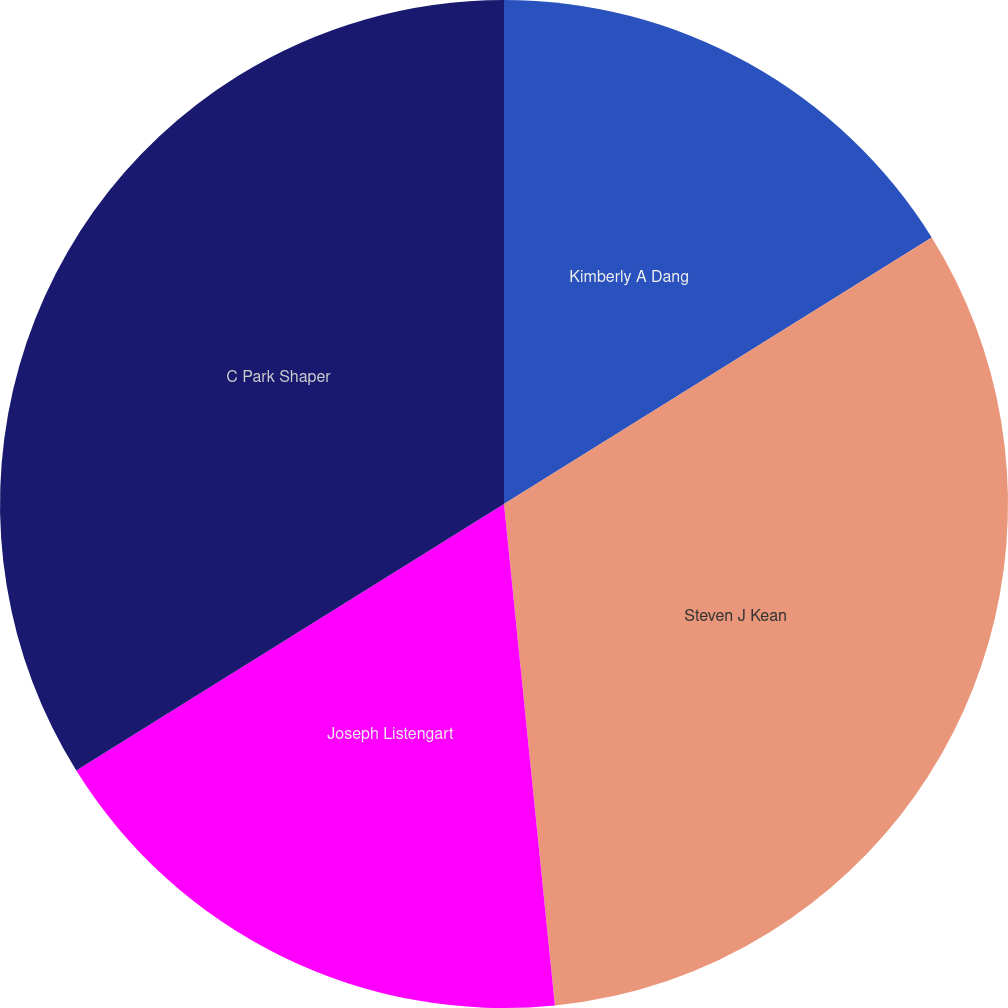Convert chart to OTSL. <chart><loc_0><loc_0><loc_500><loc_500><pie_chart><fcel>Kimberly A Dang<fcel>Steven J Kean<fcel>Joseph Listengart<fcel>C Park Shaper<nl><fcel>16.13%<fcel>32.26%<fcel>17.74%<fcel>33.87%<nl></chart> 